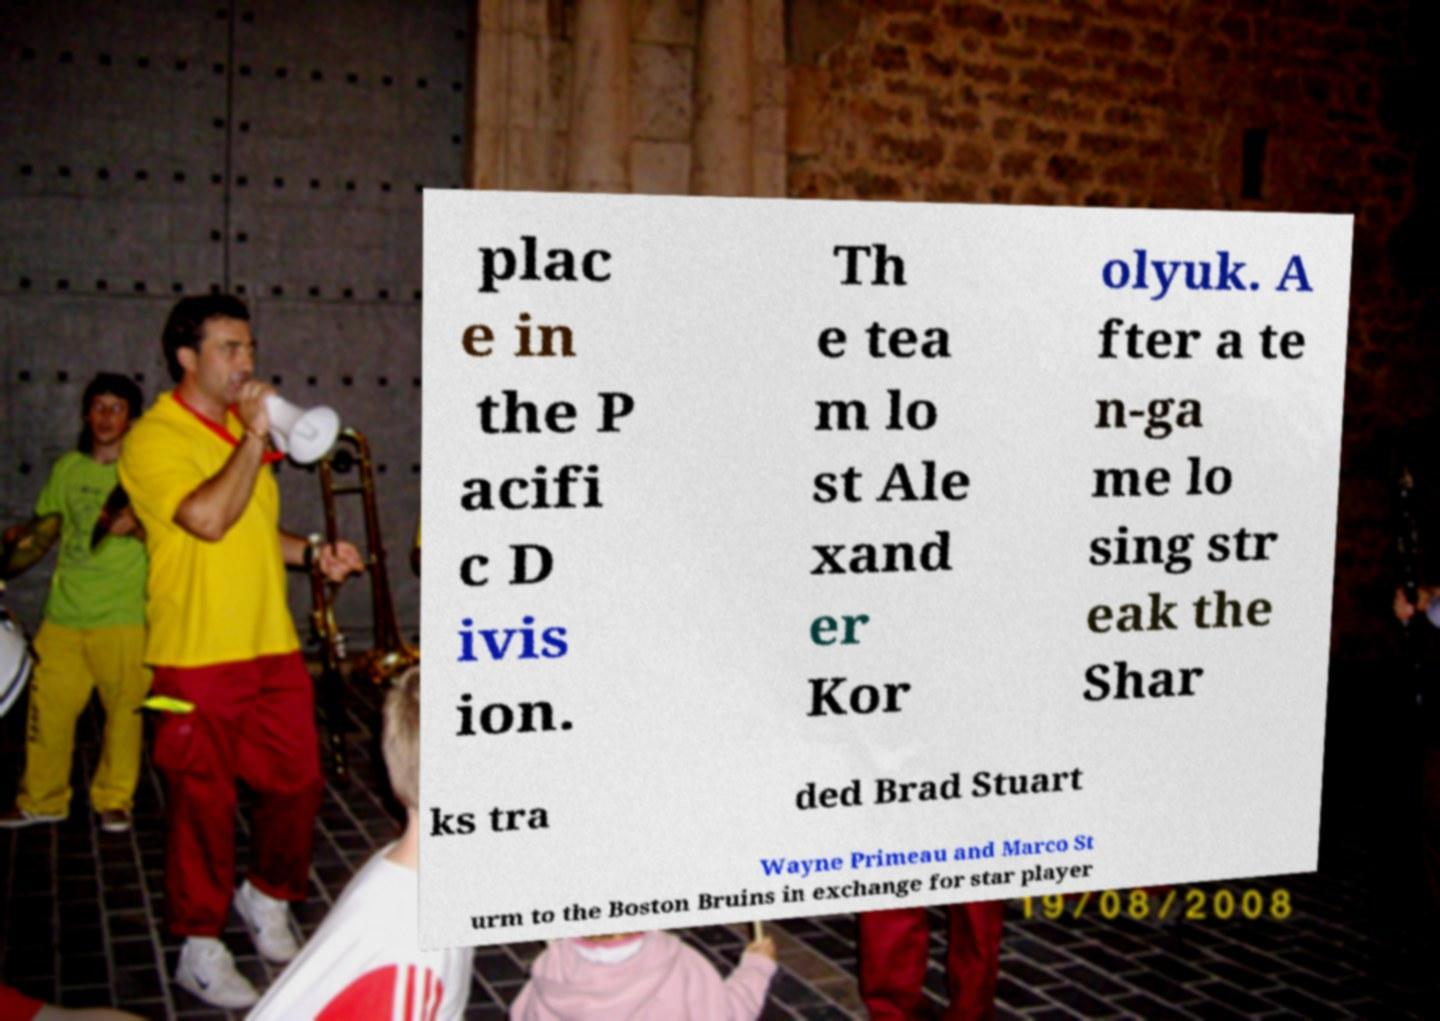Can you accurately transcribe the text from the provided image for me? plac e in the P acifi c D ivis ion. Th e tea m lo st Ale xand er Kor olyuk. A fter a te n-ga me lo sing str eak the Shar ks tra ded Brad Stuart Wayne Primeau and Marco St urm to the Boston Bruins in exchange for star player 